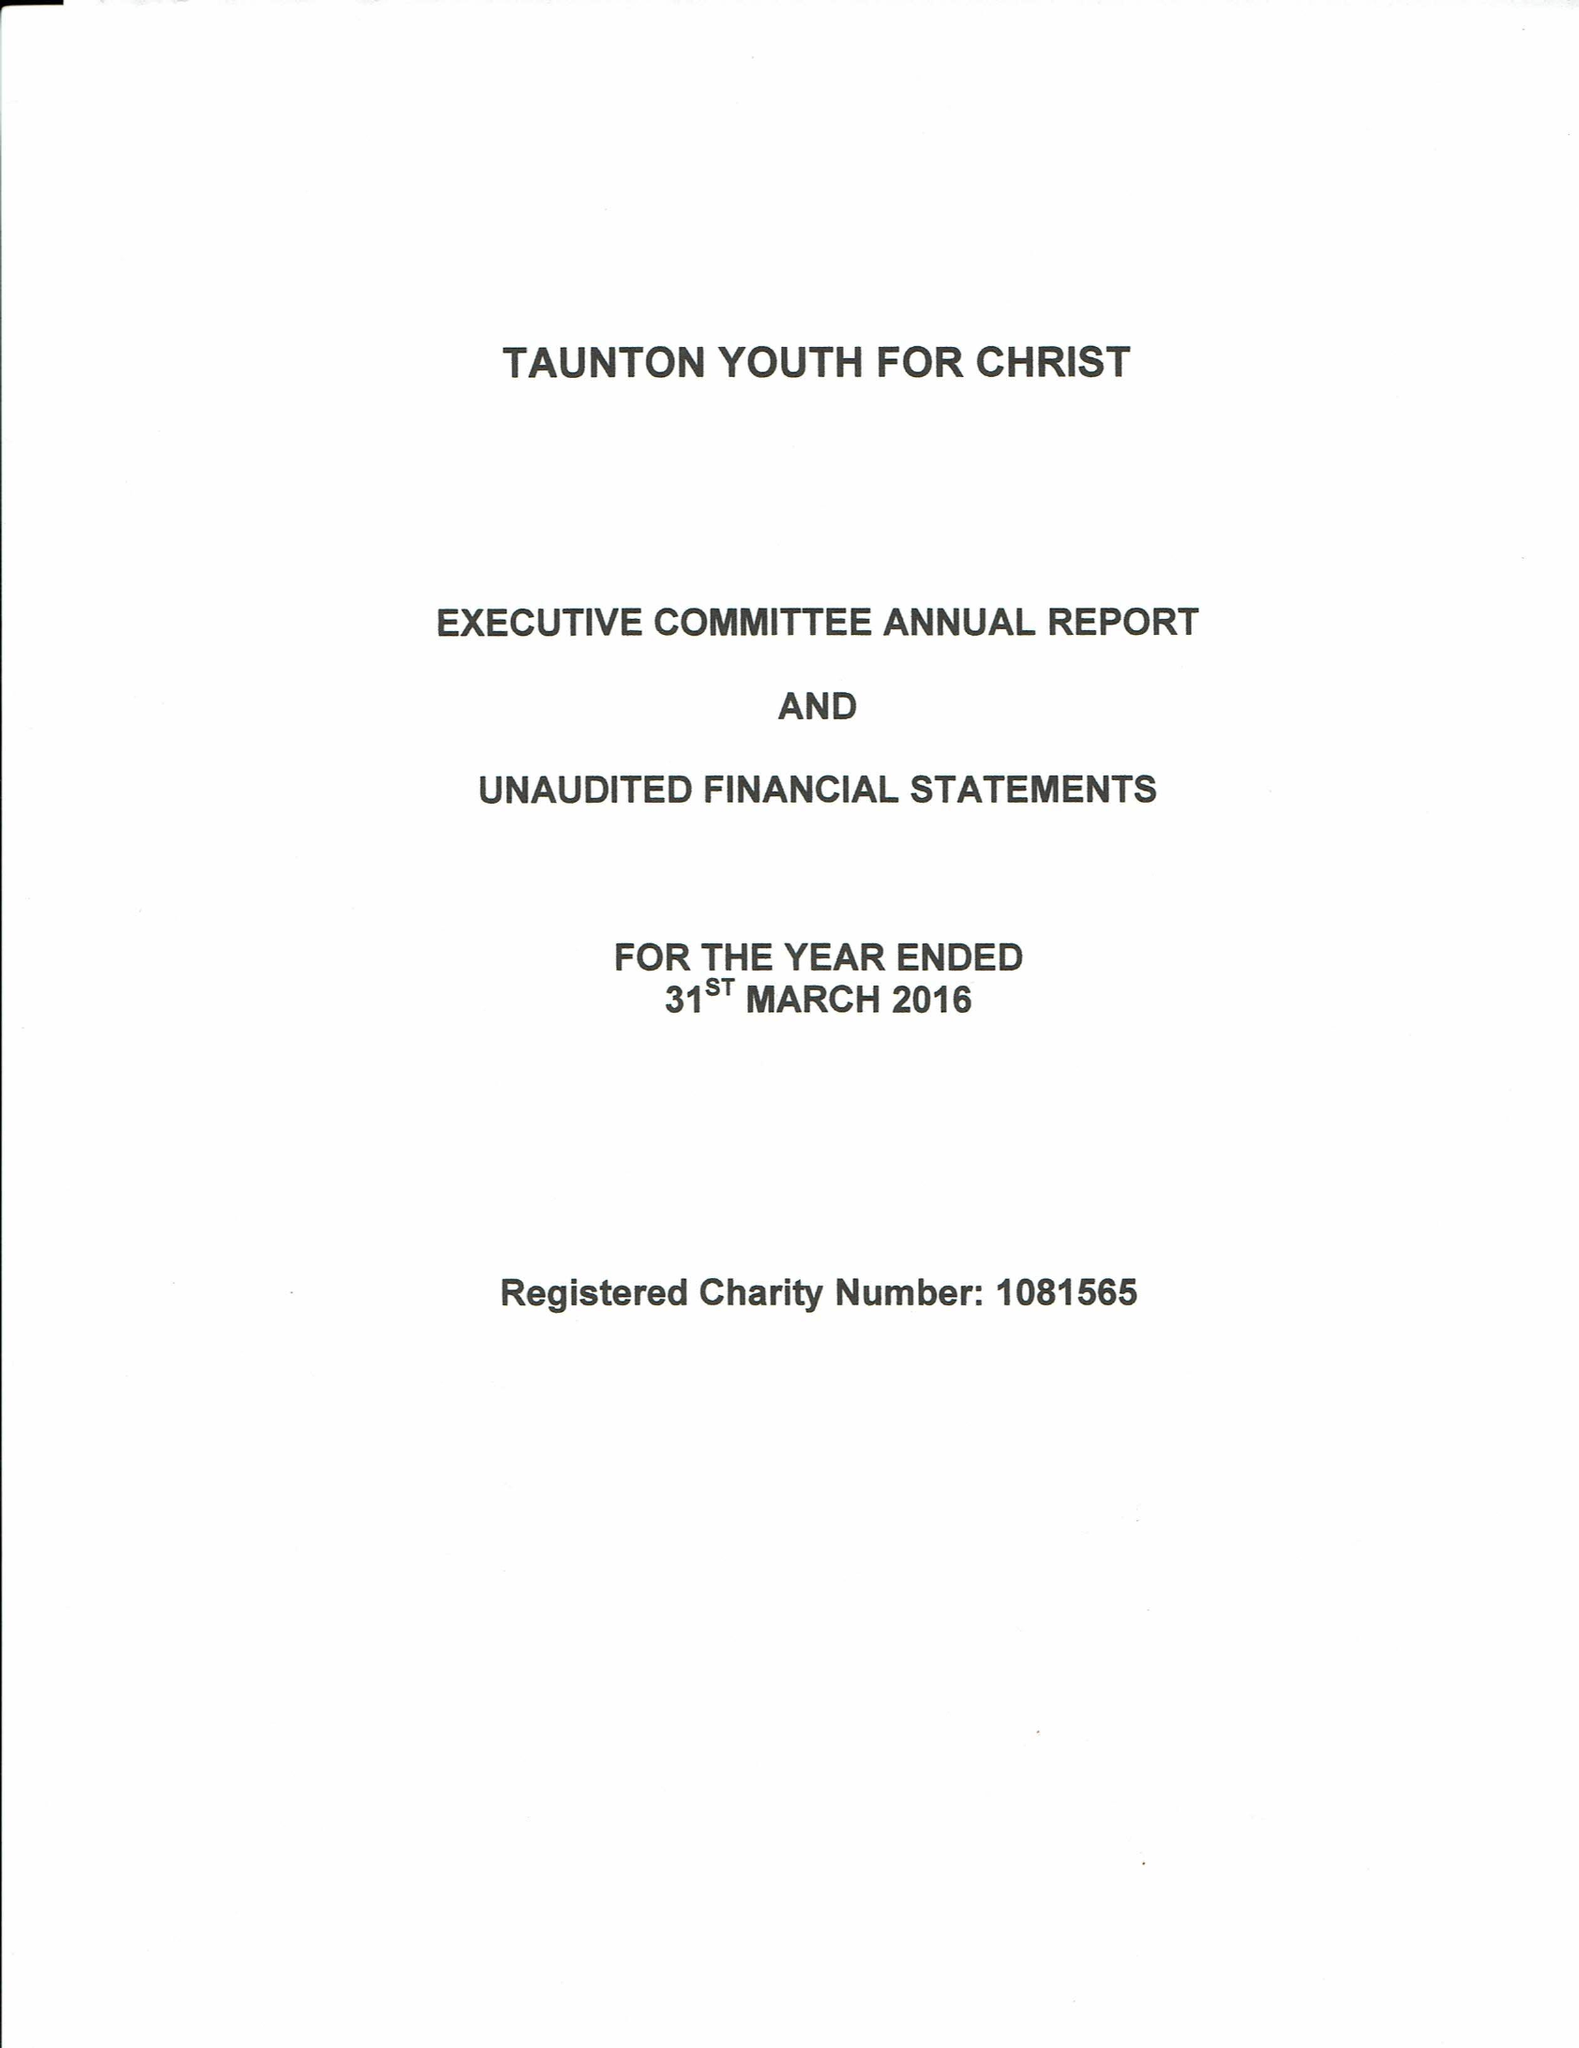What is the value for the report_date?
Answer the question using a single word or phrase. 2016-03-31 